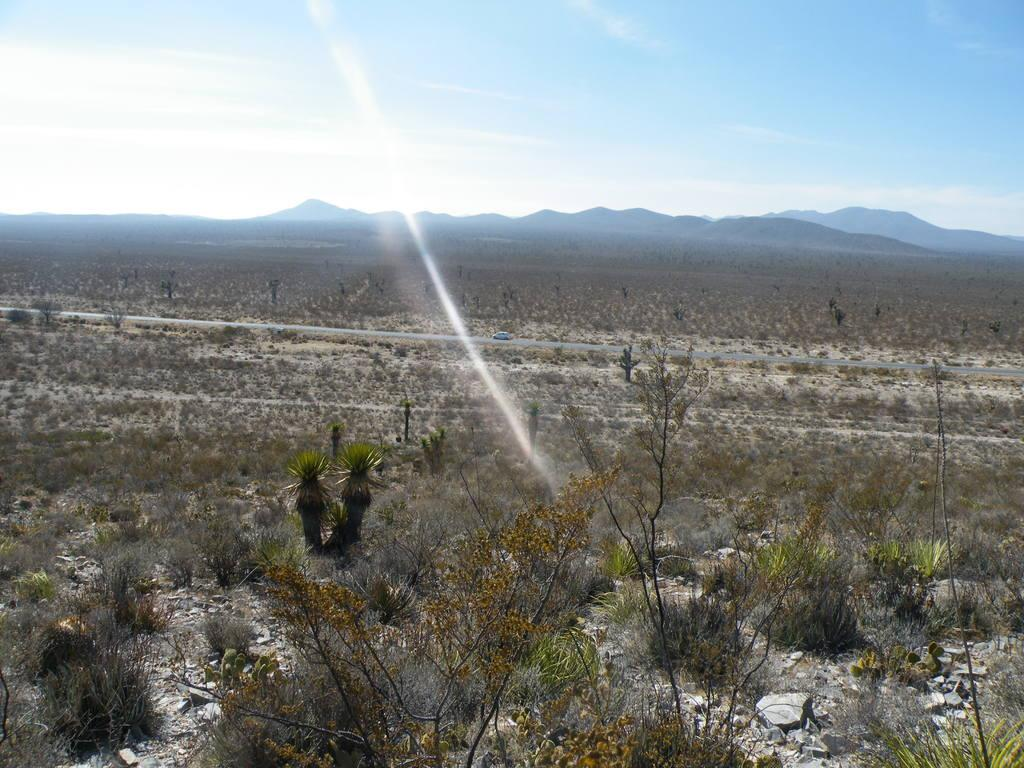What can be seen on the surface in the foreground of the image? There are planets on the surface in the foreground of the image. What type of transportation is visible in the image? There is a vehicle on the road in the image. What can be seen in the distance in the image? There are hills visible in the background of the image. What is visible in the sky in the image? There are clouds in the sky in the image. Can you hear someone coughing in the image? There is no auditory information provided in the image, so it is impossible to determine if someone is coughing. Is there any thunder visible in the image? There is no thunder present in the image; only clouds are visible in the sky. 